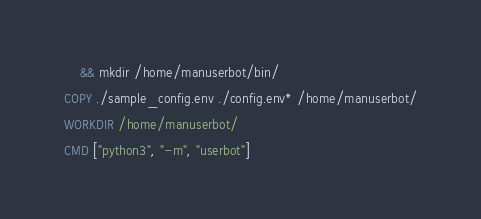Convert code to text. <code><loc_0><loc_0><loc_500><loc_500><_Dockerfile_>    && mkdir /home/manuserbot/bin/

COPY ./sample_config.env ./config.env* /home/manuserbot/

WORKDIR /home/manuserbot/

CMD ["python3", "-m", "userbot"]
</code> 